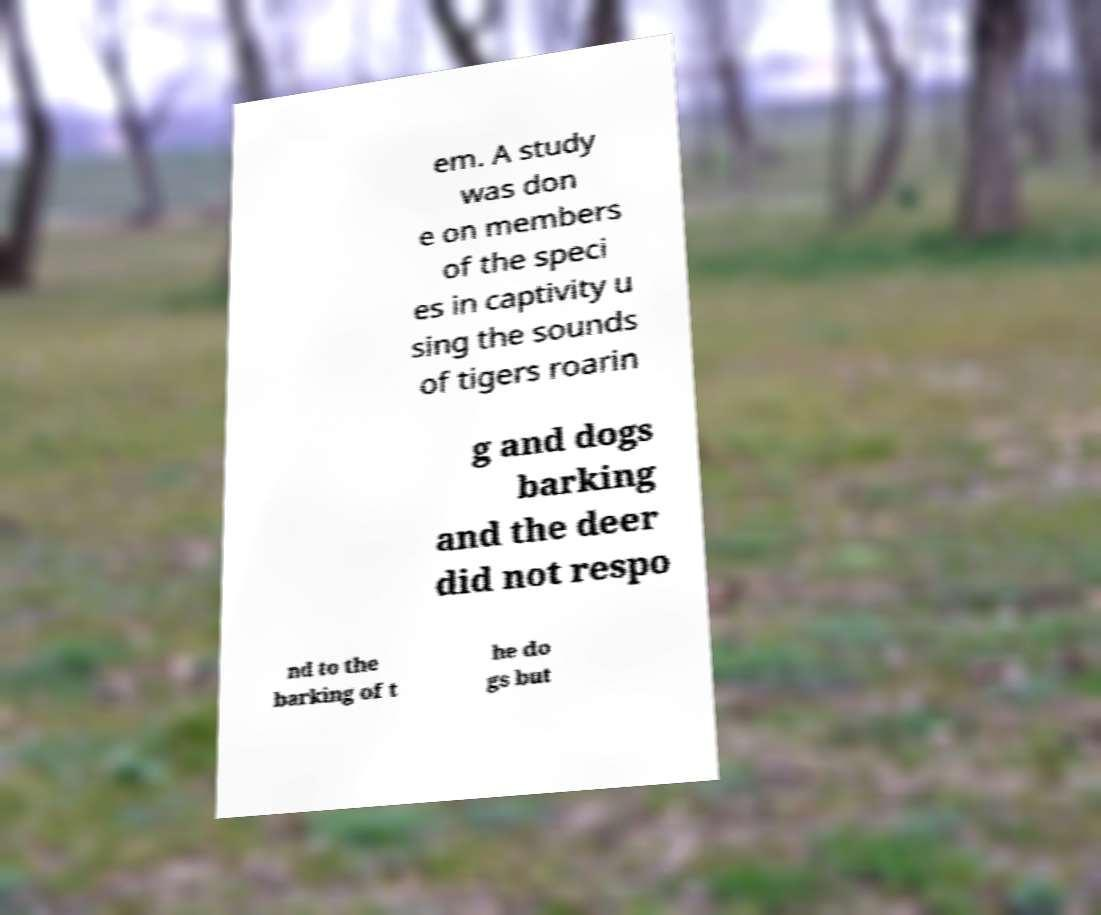Can you accurately transcribe the text from the provided image for me? em. A study was don e on members of the speci es in captivity u sing the sounds of tigers roarin g and dogs barking and the deer did not respo nd to the barking of t he do gs but 